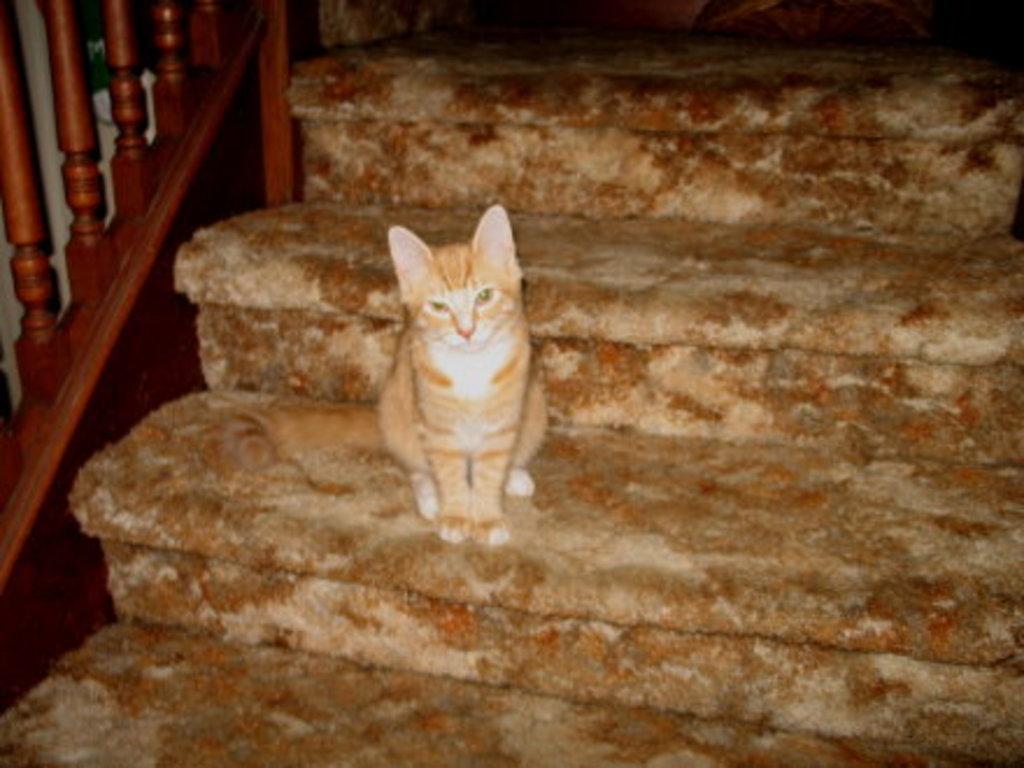In one or two sentences, can you explain what this image depicts? In this picture I can see a cat on the stairs, and there are balusters. 